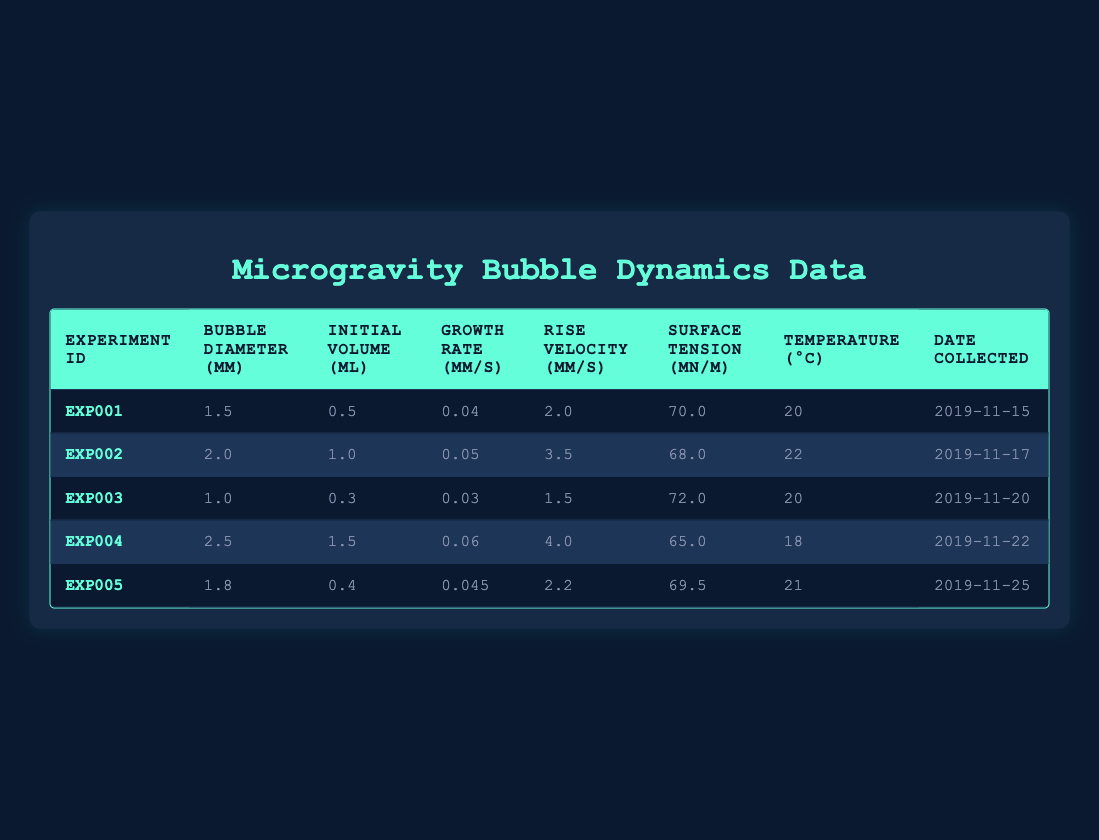What is the surface tension of the bubble in experiment EXP004? The surface tension in experiment EXP004 is listed in the table as 65.0 mN/m.
Answer: 65.0 mN/m Which experiment had the highest rise velocity? To find the highest rise velocity, we compare the rise velocities in each experiment. The highest value is 4.0 mm/s in experiment EXP004.
Answer: 4.0 mm/s What is the average growth rate of bubbles across all experiments? We sum the growth rates from each experiment: 0.04 + 0.05 + 0.03 + 0.06 + 0.045 = 0.235 mm/s. Then, divide by the number of experiments (5) to get the average: 0.235 / 5 = 0.047 mm/s.
Answer: 0.047 mm/s Is the initial volume of the bubble in experiment EXP005 greater than 0.5 ml? The initial volume in experiment EXP005 is 0.4 ml, which is less than 0.5 ml. Therefore, the answer is no.
Answer: No What is the relationship between bubble diameter and rise velocity based on the table data? To analyze this relationship, we can observe that as the bubble diameter increases, the rise velocity also tends to increase. This is evident as experiment EXP002 (2.0 mm diameter) has a rise velocity of 3.5 mm/s, while experiment EXP004 (2.5 mm diameter) has a rise velocity of 4.0 mm/s, suggesting a positive correlation.
Answer: A positive correlation exists 